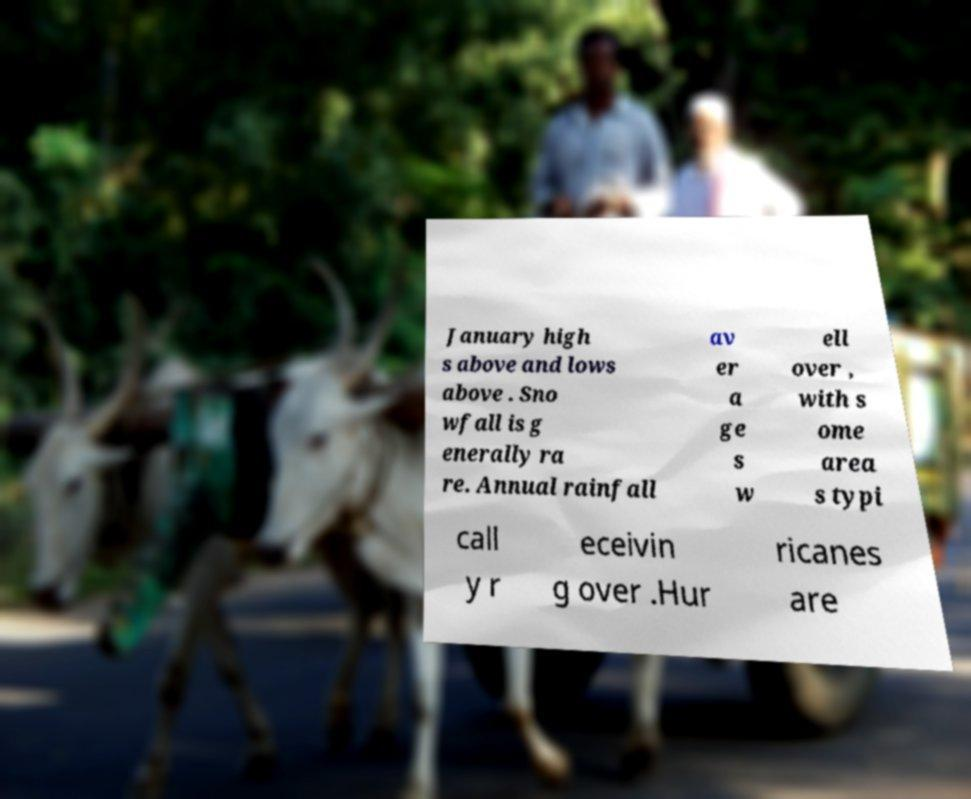What messages or text are displayed in this image? I need them in a readable, typed format. January high s above and lows above . Sno wfall is g enerally ra re. Annual rainfall av er a ge s w ell over , with s ome area s typi call y r eceivin g over .Hur ricanes are 